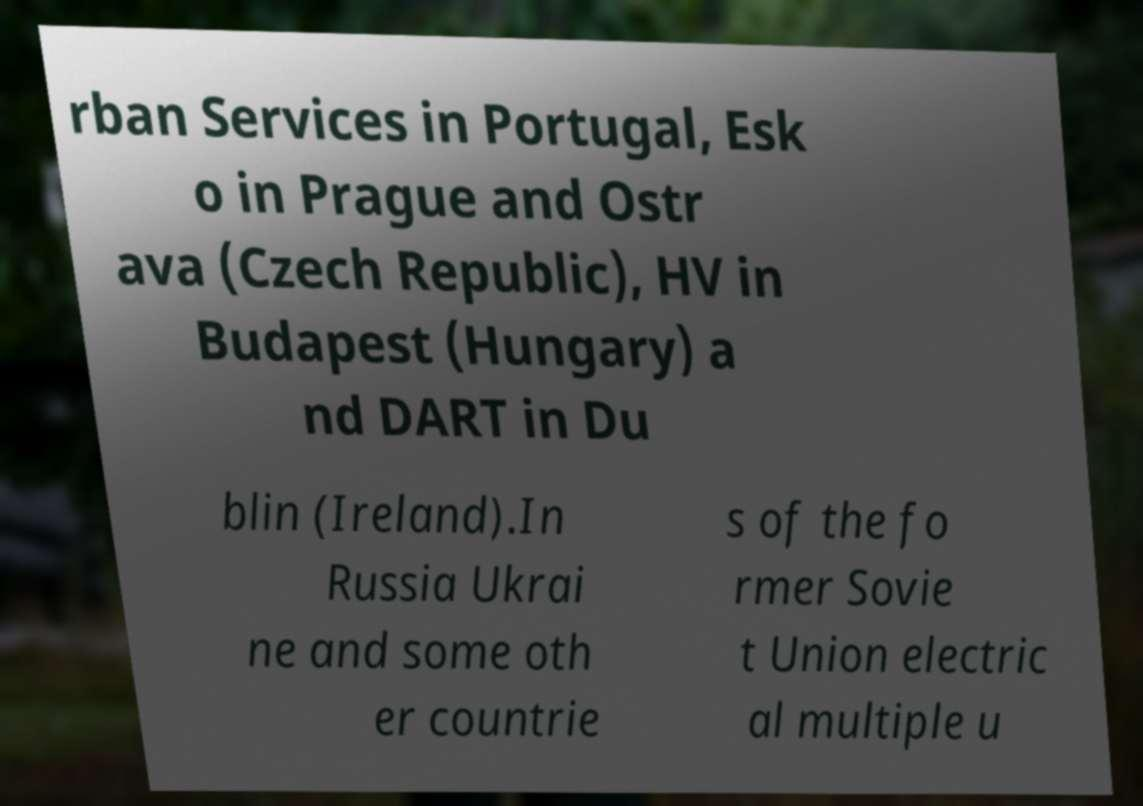Could you assist in decoding the text presented in this image and type it out clearly? rban Services in Portugal, Esk o in Prague and Ostr ava (Czech Republic), HV in Budapest (Hungary) a nd DART in Du blin (Ireland).In Russia Ukrai ne and some oth er countrie s of the fo rmer Sovie t Union electric al multiple u 